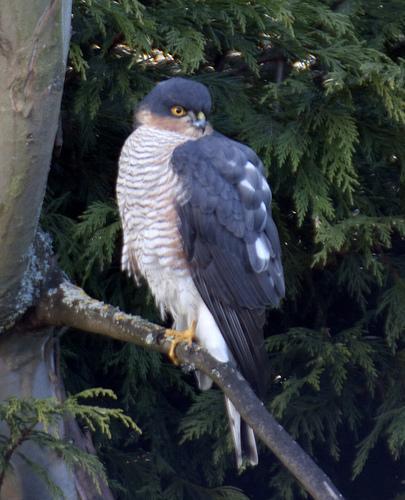How many birds in the tree branch?
Give a very brief answer. 1. 